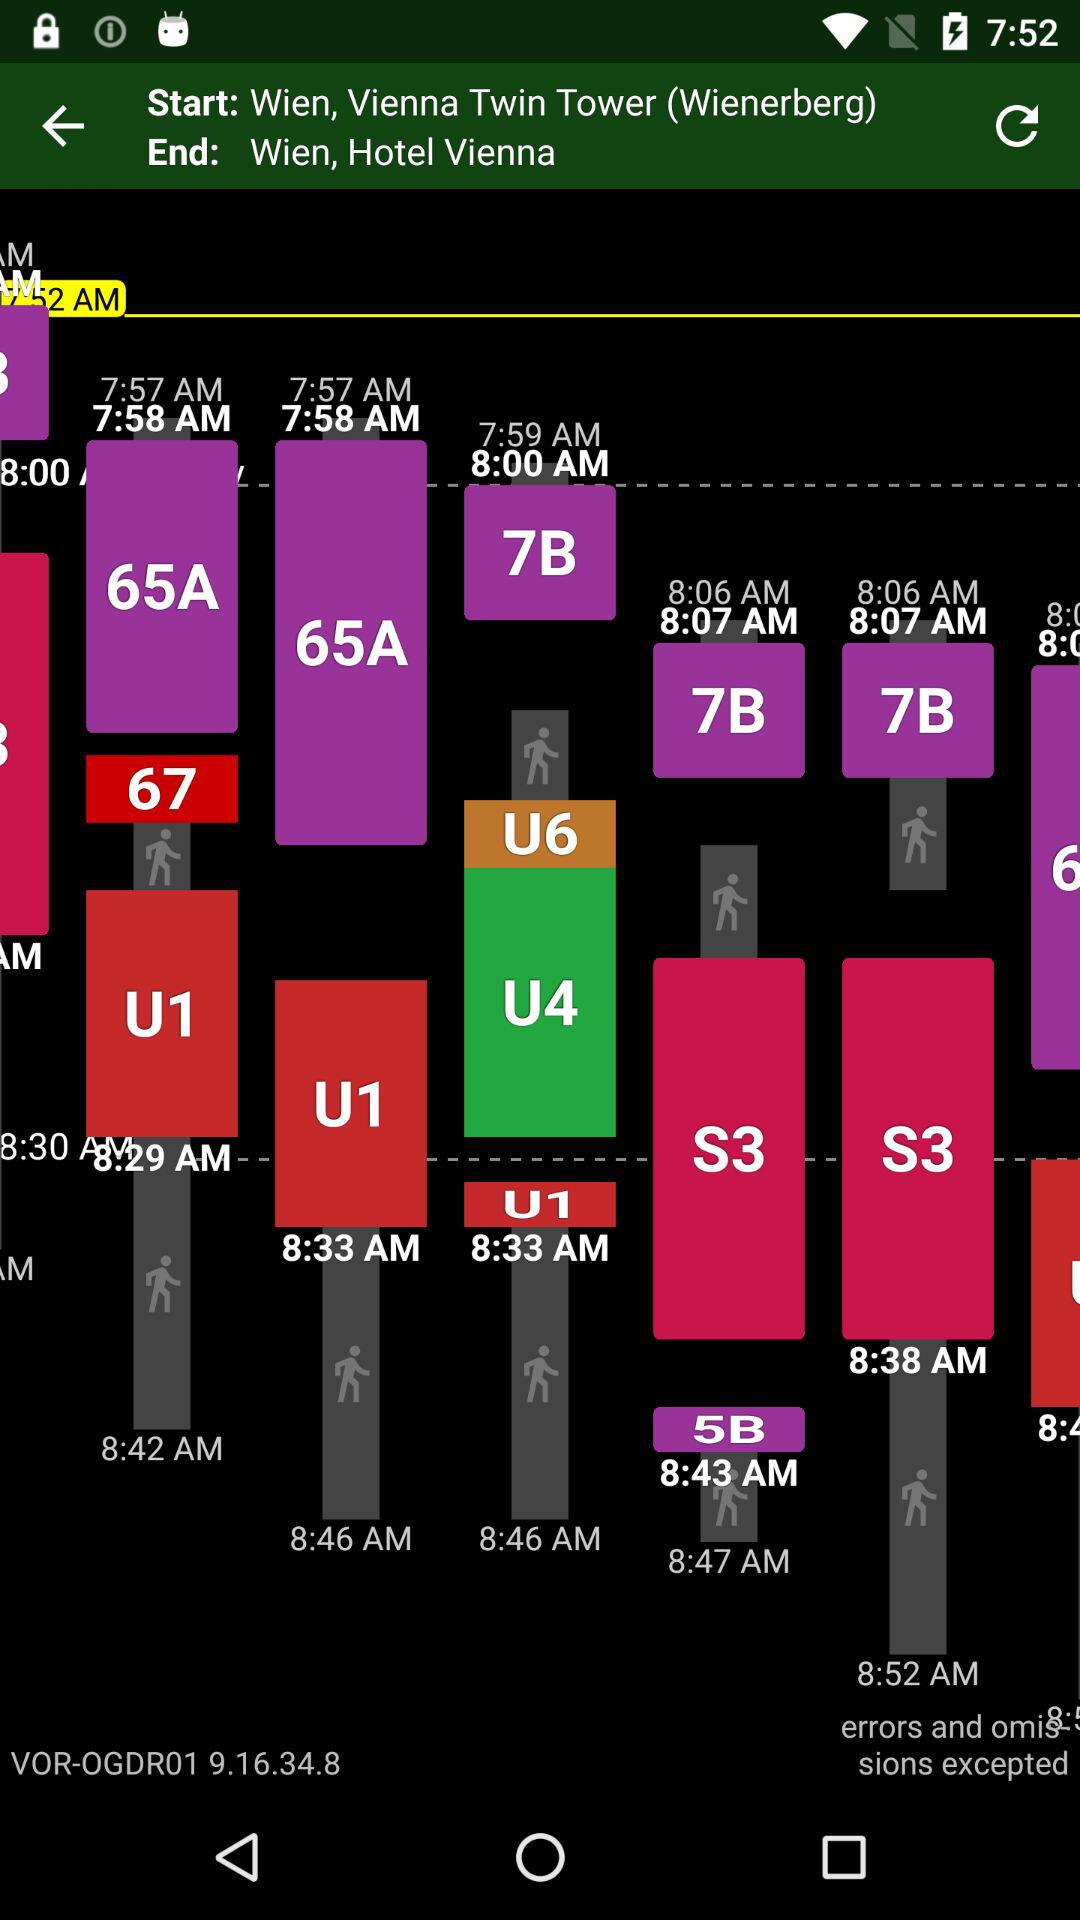What is the version? The version is VOR-OGDR01 9.16.34.8. 